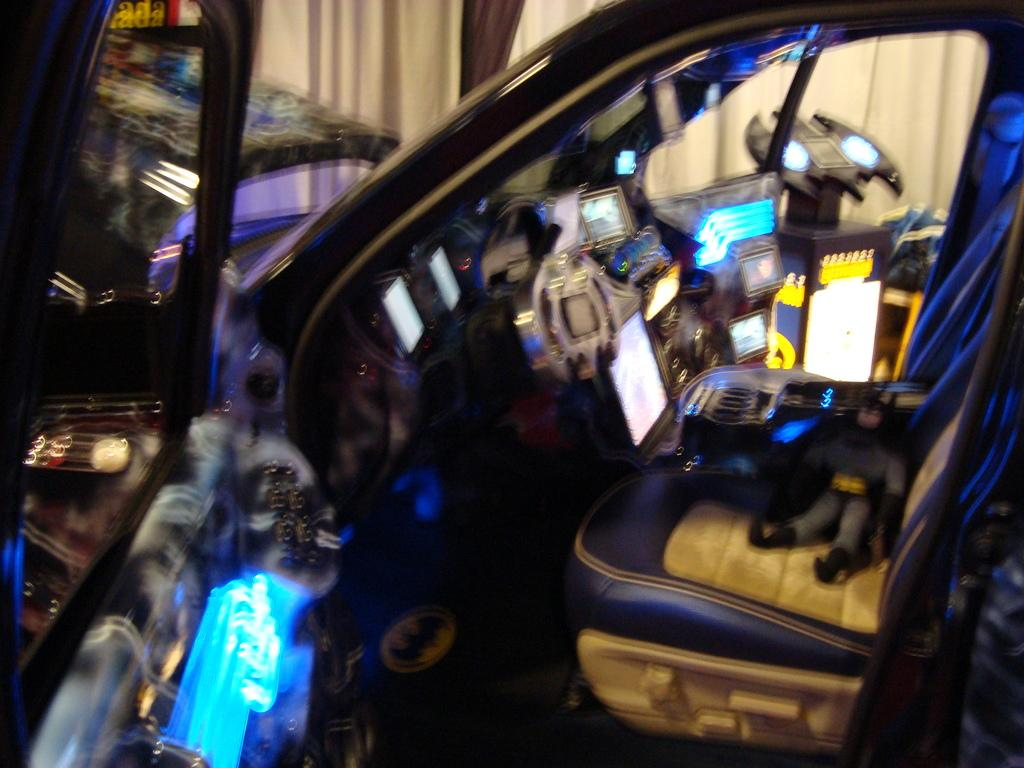What is the main subject in the image that has a black color? There is a black color thing in the image. Can you describe any other objects or elements in the image? There are other stuffs in the image. How many rings are visible on the black color thing in the image? There is no mention of rings in the provided facts, and therefore we cannot determine if any rings are visible on the black color thing in the image. 